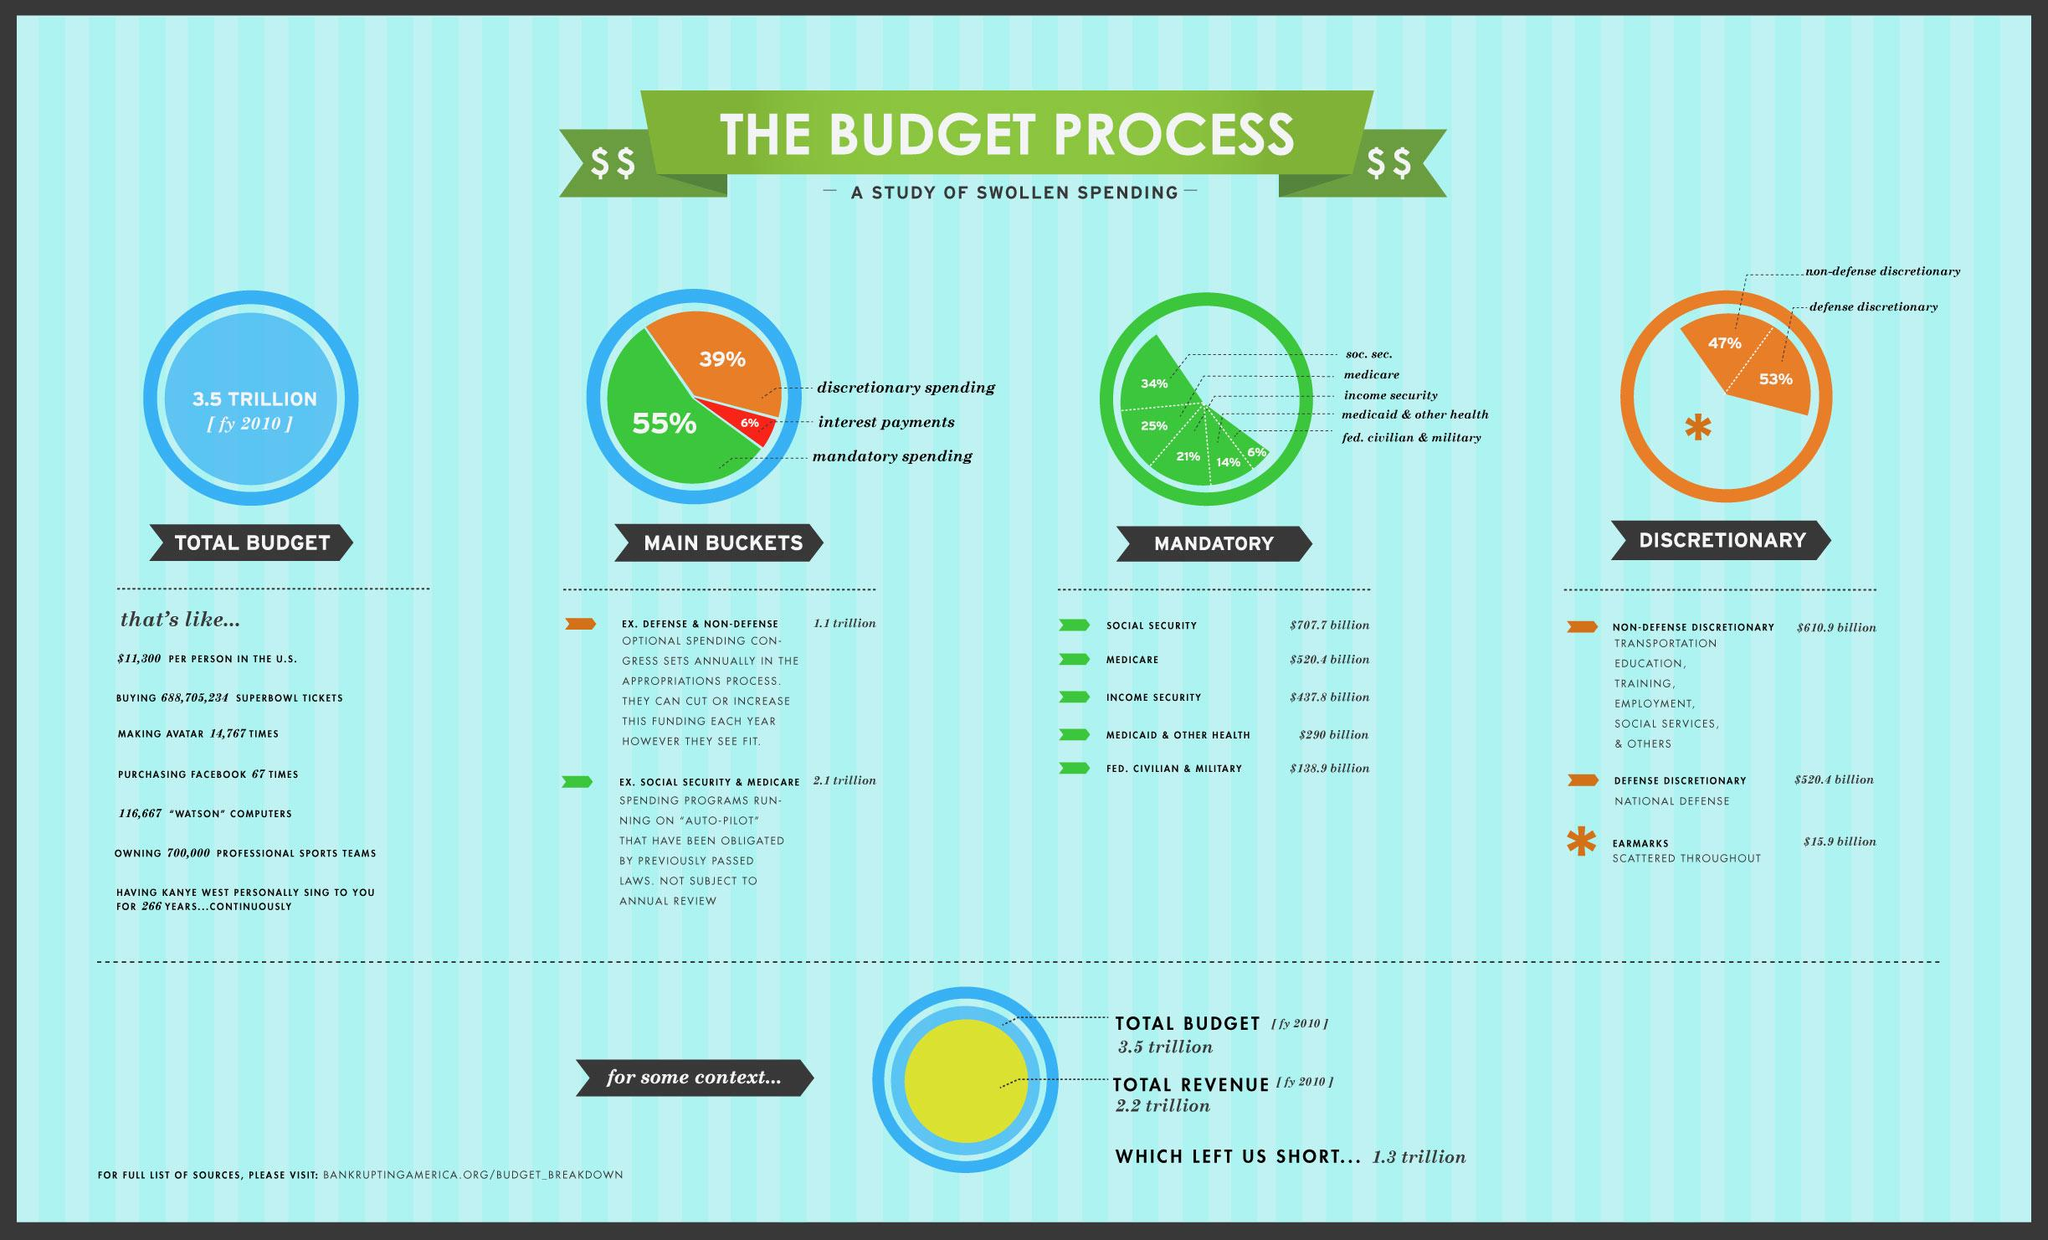Specify some key components in this picture. Social Security is the program that receives the highest amount under mandatory spending, according to the latest data. The color green represents mandatory expenditure in the pie charts given in the infographic. The allotted amount of money for interest payments in the fiscal year 2010 was approximately .3 trillion dollars. Interest payments on government loans are not considered discretionary or mandatory expenditures. There are 5 mandatory expenditure-funded sectors listed in the infographic. 